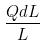<formula> <loc_0><loc_0><loc_500><loc_500>\frac { Q d L } { L }</formula> 